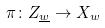<formula> <loc_0><loc_0><loc_500><loc_500>\pi \colon Z _ { \underline { w } } \rightarrow X _ { w }</formula> 